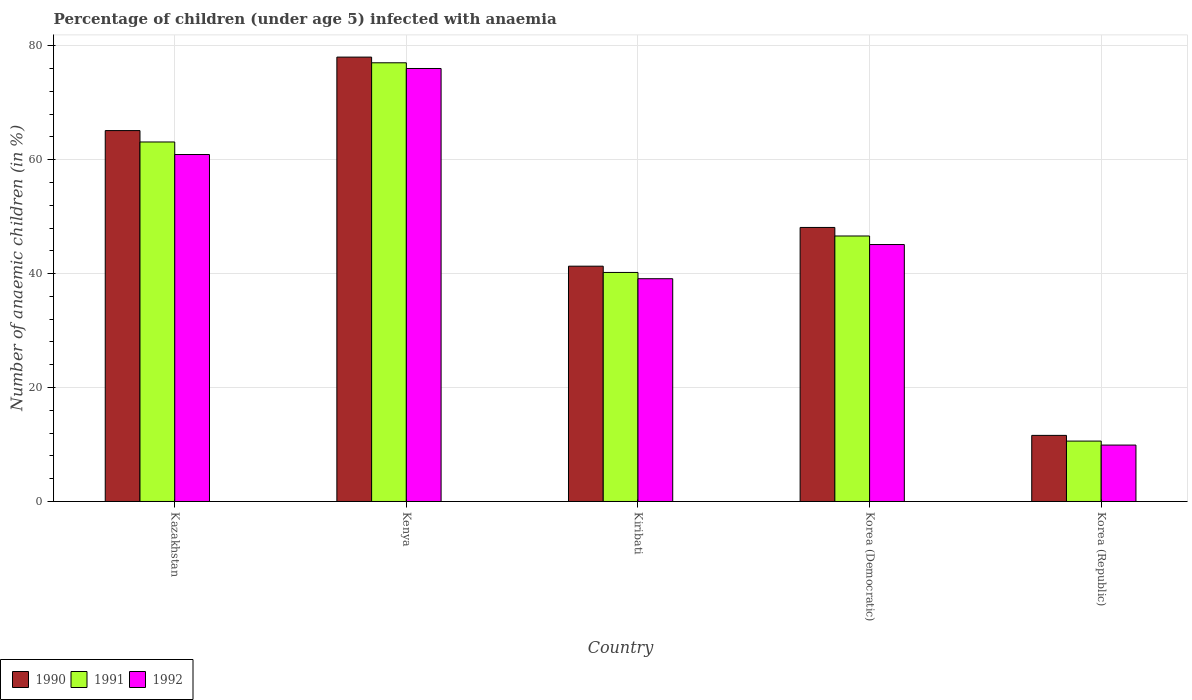How many different coloured bars are there?
Make the answer very short. 3. How many groups of bars are there?
Your response must be concise. 5. Are the number of bars per tick equal to the number of legend labels?
Ensure brevity in your answer.  Yes. Are the number of bars on each tick of the X-axis equal?
Offer a terse response. Yes. What is the label of the 4th group of bars from the left?
Keep it short and to the point. Korea (Democratic). What is the percentage of children infected with anaemia in in 1990 in Kenya?
Provide a short and direct response. 78. In which country was the percentage of children infected with anaemia in in 1991 maximum?
Offer a terse response. Kenya. In which country was the percentage of children infected with anaemia in in 1992 minimum?
Your response must be concise. Korea (Republic). What is the total percentage of children infected with anaemia in in 1991 in the graph?
Your response must be concise. 237.5. What is the difference between the percentage of children infected with anaemia in in 1991 in Kenya and that in Korea (Democratic)?
Your answer should be very brief. 30.4. What is the difference between the percentage of children infected with anaemia in in 1991 in Kenya and the percentage of children infected with anaemia in in 1992 in Kiribati?
Ensure brevity in your answer.  37.9. What is the average percentage of children infected with anaemia in in 1991 per country?
Keep it short and to the point. 47.5. What is the difference between the percentage of children infected with anaemia in of/in 1990 and percentage of children infected with anaemia in of/in 1992 in Kazakhstan?
Provide a short and direct response. 4.2. What is the ratio of the percentage of children infected with anaemia in in 1991 in Kenya to that in Korea (Democratic)?
Give a very brief answer. 1.65. What is the difference between the highest and the second highest percentage of children infected with anaemia in in 1990?
Your answer should be very brief. -17. What is the difference between the highest and the lowest percentage of children infected with anaemia in in 1992?
Your answer should be very brief. 66.1. In how many countries, is the percentage of children infected with anaemia in in 1991 greater than the average percentage of children infected with anaemia in in 1991 taken over all countries?
Offer a very short reply. 2. Is it the case that in every country, the sum of the percentage of children infected with anaemia in in 1990 and percentage of children infected with anaemia in in 1992 is greater than the percentage of children infected with anaemia in in 1991?
Keep it short and to the point. Yes. What is the difference between two consecutive major ticks on the Y-axis?
Offer a terse response. 20. Are the values on the major ticks of Y-axis written in scientific E-notation?
Keep it short and to the point. No. Does the graph contain any zero values?
Ensure brevity in your answer.  No. Does the graph contain grids?
Your answer should be very brief. Yes. How many legend labels are there?
Provide a succinct answer. 3. What is the title of the graph?
Provide a succinct answer. Percentage of children (under age 5) infected with anaemia. What is the label or title of the X-axis?
Offer a terse response. Country. What is the label or title of the Y-axis?
Your answer should be compact. Number of anaemic children (in %). What is the Number of anaemic children (in %) of 1990 in Kazakhstan?
Ensure brevity in your answer.  65.1. What is the Number of anaemic children (in %) in 1991 in Kazakhstan?
Offer a very short reply. 63.1. What is the Number of anaemic children (in %) of 1992 in Kazakhstan?
Offer a terse response. 60.9. What is the Number of anaemic children (in %) in 1992 in Kenya?
Your answer should be very brief. 76. What is the Number of anaemic children (in %) in 1990 in Kiribati?
Keep it short and to the point. 41.3. What is the Number of anaemic children (in %) in 1991 in Kiribati?
Ensure brevity in your answer.  40.2. What is the Number of anaemic children (in %) of 1992 in Kiribati?
Provide a succinct answer. 39.1. What is the Number of anaemic children (in %) in 1990 in Korea (Democratic)?
Ensure brevity in your answer.  48.1. What is the Number of anaemic children (in %) in 1991 in Korea (Democratic)?
Give a very brief answer. 46.6. What is the Number of anaemic children (in %) of 1992 in Korea (Democratic)?
Offer a very short reply. 45.1. What is the Number of anaemic children (in %) in 1990 in Korea (Republic)?
Give a very brief answer. 11.6. What is the Number of anaemic children (in %) of 1991 in Korea (Republic)?
Provide a short and direct response. 10.6. What is the Number of anaemic children (in %) in 1992 in Korea (Republic)?
Provide a short and direct response. 9.9. Across all countries, what is the maximum Number of anaemic children (in %) of 1991?
Your response must be concise. 77. Across all countries, what is the maximum Number of anaemic children (in %) of 1992?
Offer a very short reply. 76. Across all countries, what is the minimum Number of anaemic children (in %) of 1991?
Your answer should be compact. 10.6. What is the total Number of anaemic children (in %) of 1990 in the graph?
Give a very brief answer. 244.1. What is the total Number of anaemic children (in %) in 1991 in the graph?
Keep it short and to the point. 237.5. What is the total Number of anaemic children (in %) in 1992 in the graph?
Your answer should be very brief. 231. What is the difference between the Number of anaemic children (in %) in 1992 in Kazakhstan and that in Kenya?
Your answer should be compact. -15.1. What is the difference between the Number of anaemic children (in %) in 1990 in Kazakhstan and that in Kiribati?
Make the answer very short. 23.8. What is the difference between the Number of anaemic children (in %) in 1991 in Kazakhstan and that in Kiribati?
Make the answer very short. 22.9. What is the difference between the Number of anaemic children (in %) in 1992 in Kazakhstan and that in Kiribati?
Give a very brief answer. 21.8. What is the difference between the Number of anaemic children (in %) of 1990 in Kazakhstan and that in Korea (Democratic)?
Provide a succinct answer. 17. What is the difference between the Number of anaemic children (in %) in 1992 in Kazakhstan and that in Korea (Democratic)?
Your response must be concise. 15.8. What is the difference between the Number of anaemic children (in %) in 1990 in Kazakhstan and that in Korea (Republic)?
Offer a terse response. 53.5. What is the difference between the Number of anaemic children (in %) of 1991 in Kazakhstan and that in Korea (Republic)?
Your answer should be compact. 52.5. What is the difference between the Number of anaemic children (in %) of 1990 in Kenya and that in Kiribati?
Your answer should be compact. 36.7. What is the difference between the Number of anaemic children (in %) in 1991 in Kenya and that in Kiribati?
Offer a very short reply. 36.8. What is the difference between the Number of anaemic children (in %) in 1992 in Kenya and that in Kiribati?
Offer a very short reply. 36.9. What is the difference between the Number of anaemic children (in %) of 1990 in Kenya and that in Korea (Democratic)?
Your answer should be very brief. 29.9. What is the difference between the Number of anaemic children (in %) of 1991 in Kenya and that in Korea (Democratic)?
Make the answer very short. 30.4. What is the difference between the Number of anaemic children (in %) of 1992 in Kenya and that in Korea (Democratic)?
Your answer should be very brief. 30.9. What is the difference between the Number of anaemic children (in %) in 1990 in Kenya and that in Korea (Republic)?
Make the answer very short. 66.4. What is the difference between the Number of anaemic children (in %) of 1991 in Kenya and that in Korea (Republic)?
Make the answer very short. 66.4. What is the difference between the Number of anaemic children (in %) of 1992 in Kenya and that in Korea (Republic)?
Provide a short and direct response. 66.1. What is the difference between the Number of anaemic children (in %) in 1990 in Kiribati and that in Korea (Democratic)?
Give a very brief answer. -6.8. What is the difference between the Number of anaemic children (in %) in 1991 in Kiribati and that in Korea (Democratic)?
Make the answer very short. -6.4. What is the difference between the Number of anaemic children (in %) of 1992 in Kiribati and that in Korea (Democratic)?
Keep it short and to the point. -6. What is the difference between the Number of anaemic children (in %) of 1990 in Kiribati and that in Korea (Republic)?
Provide a short and direct response. 29.7. What is the difference between the Number of anaemic children (in %) of 1991 in Kiribati and that in Korea (Republic)?
Keep it short and to the point. 29.6. What is the difference between the Number of anaemic children (in %) of 1992 in Kiribati and that in Korea (Republic)?
Provide a succinct answer. 29.2. What is the difference between the Number of anaemic children (in %) of 1990 in Korea (Democratic) and that in Korea (Republic)?
Give a very brief answer. 36.5. What is the difference between the Number of anaemic children (in %) in 1991 in Korea (Democratic) and that in Korea (Republic)?
Offer a very short reply. 36. What is the difference between the Number of anaemic children (in %) of 1992 in Korea (Democratic) and that in Korea (Republic)?
Offer a terse response. 35.2. What is the difference between the Number of anaemic children (in %) in 1990 in Kazakhstan and the Number of anaemic children (in %) in 1992 in Kenya?
Your answer should be very brief. -10.9. What is the difference between the Number of anaemic children (in %) in 1990 in Kazakhstan and the Number of anaemic children (in %) in 1991 in Kiribati?
Keep it short and to the point. 24.9. What is the difference between the Number of anaemic children (in %) of 1990 in Kazakhstan and the Number of anaemic children (in %) of 1992 in Kiribati?
Provide a short and direct response. 26. What is the difference between the Number of anaemic children (in %) of 1991 in Kazakhstan and the Number of anaemic children (in %) of 1992 in Kiribati?
Keep it short and to the point. 24. What is the difference between the Number of anaemic children (in %) of 1990 in Kazakhstan and the Number of anaemic children (in %) of 1992 in Korea (Democratic)?
Offer a terse response. 20. What is the difference between the Number of anaemic children (in %) of 1990 in Kazakhstan and the Number of anaemic children (in %) of 1991 in Korea (Republic)?
Make the answer very short. 54.5. What is the difference between the Number of anaemic children (in %) of 1990 in Kazakhstan and the Number of anaemic children (in %) of 1992 in Korea (Republic)?
Your answer should be very brief. 55.2. What is the difference between the Number of anaemic children (in %) of 1991 in Kazakhstan and the Number of anaemic children (in %) of 1992 in Korea (Republic)?
Ensure brevity in your answer.  53.2. What is the difference between the Number of anaemic children (in %) in 1990 in Kenya and the Number of anaemic children (in %) in 1991 in Kiribati?
Offer a very short reply. 37.8. What is the difference between the Number of anaemic children (in %) in 1990 in Kenya and the Number of anaemic children (in %) in 1992 in Kiribati?
Make the answer very short. 38.9. What is the difference between the Number of anaemic children (in %) of 1991 in Kenya and the Number of anaemic children (in %) of 1992 in Kiribati?
Your answer should be compact. 37.9. What is the difference between the Number of anaemic children (in %) of 1990 in Kenya and the Number of anaemic children (in %) of 1991 in Korea (Democratic)?
Make the answer very short. 31.4. What is the difference between the Number of anaemic children (in %) of 1990 in Kenya and the Number of anaemic children (in %) of 1992 in Korea (Democratic)?
Provide a succinct answer. 32.9. What is the difference between the Number of anaemic children (in %) in 1991 in Kenya and the Number of anaemic children (in %) in 1992 in Korea (Democratic)?
Make the answer very short. 31.9. What is the difference between the Number of anaemic children (in %) in 1990 in Kenya and the Number of anaemic children (in %) in 1991 in Korea (Republic)?
Your response must be concise. 67.4. What is the difference between the Number of anaemic children (in %) in 1990 in Kenya and the Number of anaemic children (in %) in 1992 in Korea (Republic)?
Your answer should be compact. 68.1. What is the difference between the Number of anaemic children (in %) in 1991 in Kenya and the Number of anaemic children (in %) in 1992 in Korea (Republic)?
Your answer should be very brief. 67.1. What is the difference between the Number of anaemic children (in %) of 1990 in Kiribati and the Number of anaemic children (in %) of 1991 in Korea (Republic)?
Your answer should be very brief. 30.7. What is the difference between the Number of anaemic children (in %) of 1990 in Kiribati and the Number of anaemic children (in %) of 1992 in Korea (Republic)?
Your answer should be very brief. 31.4. What is the difference between the Number of anaemic children (in %) of 1991 in Kiribati and the Number of anaemic children (in %) of 1992 in Korea (Republic)?
Provide a short and direct response. 30.3. What is the difference between the Number of anaemic children (in %) of 1990 in Korea (Democratic) and the Number of anaemic children (in %) of 1991 in Korea (Republic)?
Make the answer very short. 37.5. What is the difference between the Number of anaemic children (in %) in 1990 in Korea (Democratic) and the Number of anaemic children (in %) in 1992 in Korea (Republic)?
Your answer should be compact. 38.2. What is the difference between the Number of anaemic children (in %) in 1991 in Korea (Democratic) and the Number of anaemic children (in %) in 1992 in Korea (Republic)?
Ensure brevity in your answer.  36.7. What is the average Number of anaemic children (in %) of 1990 per country?
Your answer should be compact. 48.82. What is the average Number of anaemic children (in %) of 1991 per country?
Your response must be concise. 47.5. What is the average Number of anaemic children (in %) in 1992 per country?
Your answer should be compact. 46.2. What is the difference between the Number of anaemic children (in %) of 1990 and Number of anaemic children (in %) of 1991 in Kazakhstan?
Your answer should be very brief. 2. What is the difference between the Number of anaemic children (in %) in 1990 and Number of anaemic children (in %) in 1991 in Korea (Democratic)?
Provide a succinct answer. 1.5. What is the difference between the Number of anaemic children (in %) in 1990 and Number of anaemic children (in %) in 1992 in Korea (Republic)?
Keep it short and to the point. 1.7. What is the difference between the Number of anaemic children (in %) of 1991 and Number of anaemic children (in %) of 1992 in Korea (Republic)?
Offer a terse response. 0.7. What is the ratio of the Number of anaemic children (in %) of 1990 in Kazakhstan to that in Kenya?
Your response must be concise. 0.83. What is the ratio of the Number of anaemic children (in %) of 1991 in Kazakhstan to that in Kenya?
Make the answer very short. 0.82. What is the ratio of the Number of anaemic children (in %) in 1992 in Kazakhstan to that in Kenya?
Provide a short and direct response. 0.8. What is the ratio of the Number of anaemic children (in %) of 1990 in Kazakhstan to that in Kiribati?
Provide a succinct answer. 1.58. What is the ratio of the Number of anaemic children (in %) in 1991 in Kazakhstan to that in Kiribati?
Ensure brevity in your answer.  1.57. What is the ratio of the Number of anaemic children (in %) in 1992 in Kazakhstan to that in Kiribati?
Provide a succinct answer. 1.56. What is the ratio of the Number of anaemic children (in %) in 1990 in Kazakhstan to that in Korea (Democratic)?
Make the answer very short. 1.35. What is the ratio of the Number of anaemic children (in %) of 1991 in Kazakhstan to that in Korea (Democratic)?
Provide a succinct answer. 1.35. What is the ratio of the Number of anaemic children (in %) in 1992 in Kazakhstan to that in Korea (Democratic)?
Your answer should be very brief. 1.35. What is the ratio of the Number of anaemic children (in %) of 1990 in Kazakhstan to that in Korea (Republic)?
Provide a succinct answer. 5.61. What is the ratio of the Number of anaemic children (in %) in 1991 in Kazakhstan to that in Korea (Republic)?
Make the answer very short. 5.95. What is the ratio of the Number of anaemic children (in %) in 1992 in Kazakhstan to that in Korea (Republic)?
Give a very brief answer. 6.15. What is the ratio of the Number of anaemic children (in %) in 1990 in Kenya to that in Kiribati?
Your answer should be compact. 1.89. What is the ratio of the Number of anaemic children (in %) in 1991 in Kenya to that in Kiribati?
Your answer should be very brief. 1.92. What is the ratio of the Number of anaemic children (in %) in 1992 in Kenya to that in Kiribati?
Your answer should be compact. 1.94. What is the ratio of the Number of anaemic children (in %) in 1990 in Kenya to that in Korea (Democratic)?
Your answer should be compact. 1.62. What is the ratio of the Number of anaemic children (in %) in 1991 in Kenya to that in Korea (Democratic)?
Make the answer very short. 1.65. What is the ratio of the Number of anaemic children (in %) in 1992 in Kenya to that in Korea (Democratic)?
Your response must be concise. 1.69. What is the ratio of the Number of anaemic children (in %) of 1990 in Kenya to that in Korea (Republic)?
Your answer should be compact. 6.72. What is the ratio of the Number of anaemic children (in %) in 1991 in Kenya to that in Korea (Republic)?
Your response must be concise. 7.26. What is the ratio of the Number of anaemic children (in %) of 1992 in Kenya to that in Korea (Republic)?
Offer a terse response. 7.68. What is the ratio of the Number of anaemic children (in %) of 1990 in Kiribati to that in Korea (Democratic)?
Offer a very short reply. 0.86. What is the ratio of the Number of anaemic children (in %) of 1991 in Kiribati to that in Korea (Democratic)?
Provide a succinct answer. 0.86. What is the ratio of the Number of anaemic children (in %) in 1992 in Kiribati to that in Korea (Democratic)?
Offer a terse response. 0.87. What is the ratio of the Number of anaemic children (in %) in 1990 in Kiribati to that in Korea (Republic)?
Provide a succinct answer. 3.56. What is the ratio of the Number of anaemic children (in %) of 1991 in Kiribati to that in Korea (Republic)?
Keep it short and to the point. 3.79. What is the ratio of the Number of anaemic children (in %) of 1992 in Kiribati to that in Korea (Republic)?
Provide a succinct answer. 3.95. What is the ratio of the Number of anaemic children (in %) in 1990 in Korea (Democratic) to that in Korea (Republic)?
Ensure brevity in your answer.  4.15. What is the ratio of the Number of anaemic children (in %) in 1991 in Korea (Democratic) to that in Korea (Republic)?
Your response must be concise. 4.4. What is the ratio of the Number of anaemic children (in %) of 1992 in Korea (Democratic) to that in Korea (Republic)?
Provide a short and direct response. 4.56. What is the difference between the highest and the second highest Number of anaemic children (in %) in 1991?
Your answer should be very brief. 13.9. What is the difference between the highest and the lowest Number of anaemic children (in %) of 1990?
Provide a short and direct response. 66.4. What is the difference between the highest and the lowest Number of anaemic children (in %) in 1991?
Offer a terse response. 66.4. What is the difference between the highest and the lowest Number of anaemic children (in %) of 1992?
Provide a succinct answer. 66.1. 